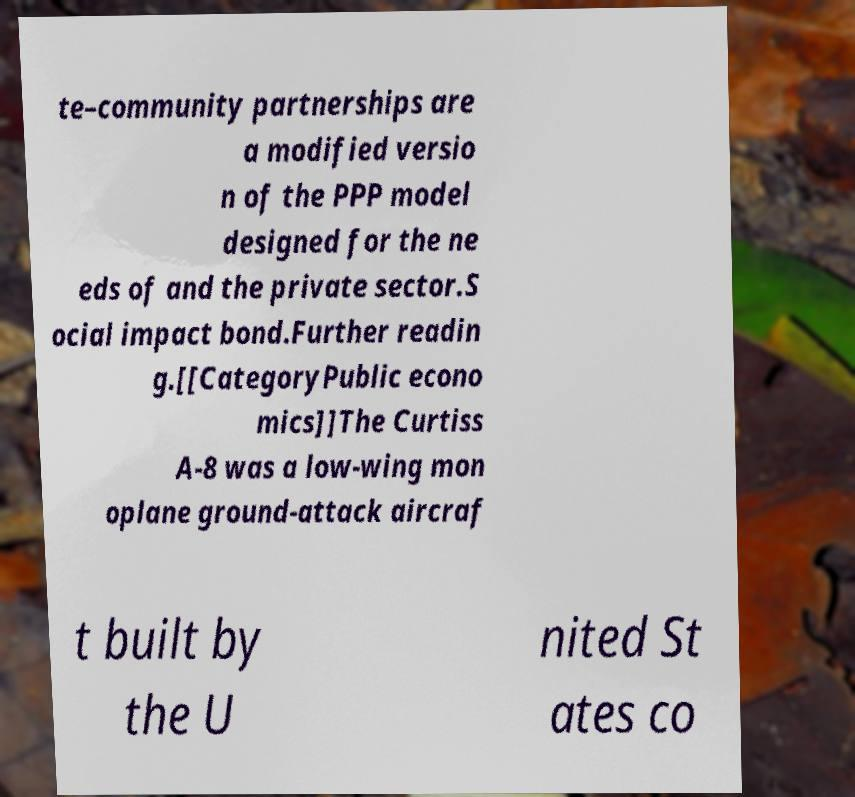Can you accurately transcribe the text from the provided image for me? te–community partnerships are a modified versio n of the PPP model designed for the ne eds of and the private sector.S ocial impact bond.Further readin g.[[CategoryPublic econo mics]]The Curtiss A-8 was a low-wing mon oplane ground-attack aircraf t built by the U nited St ates co 